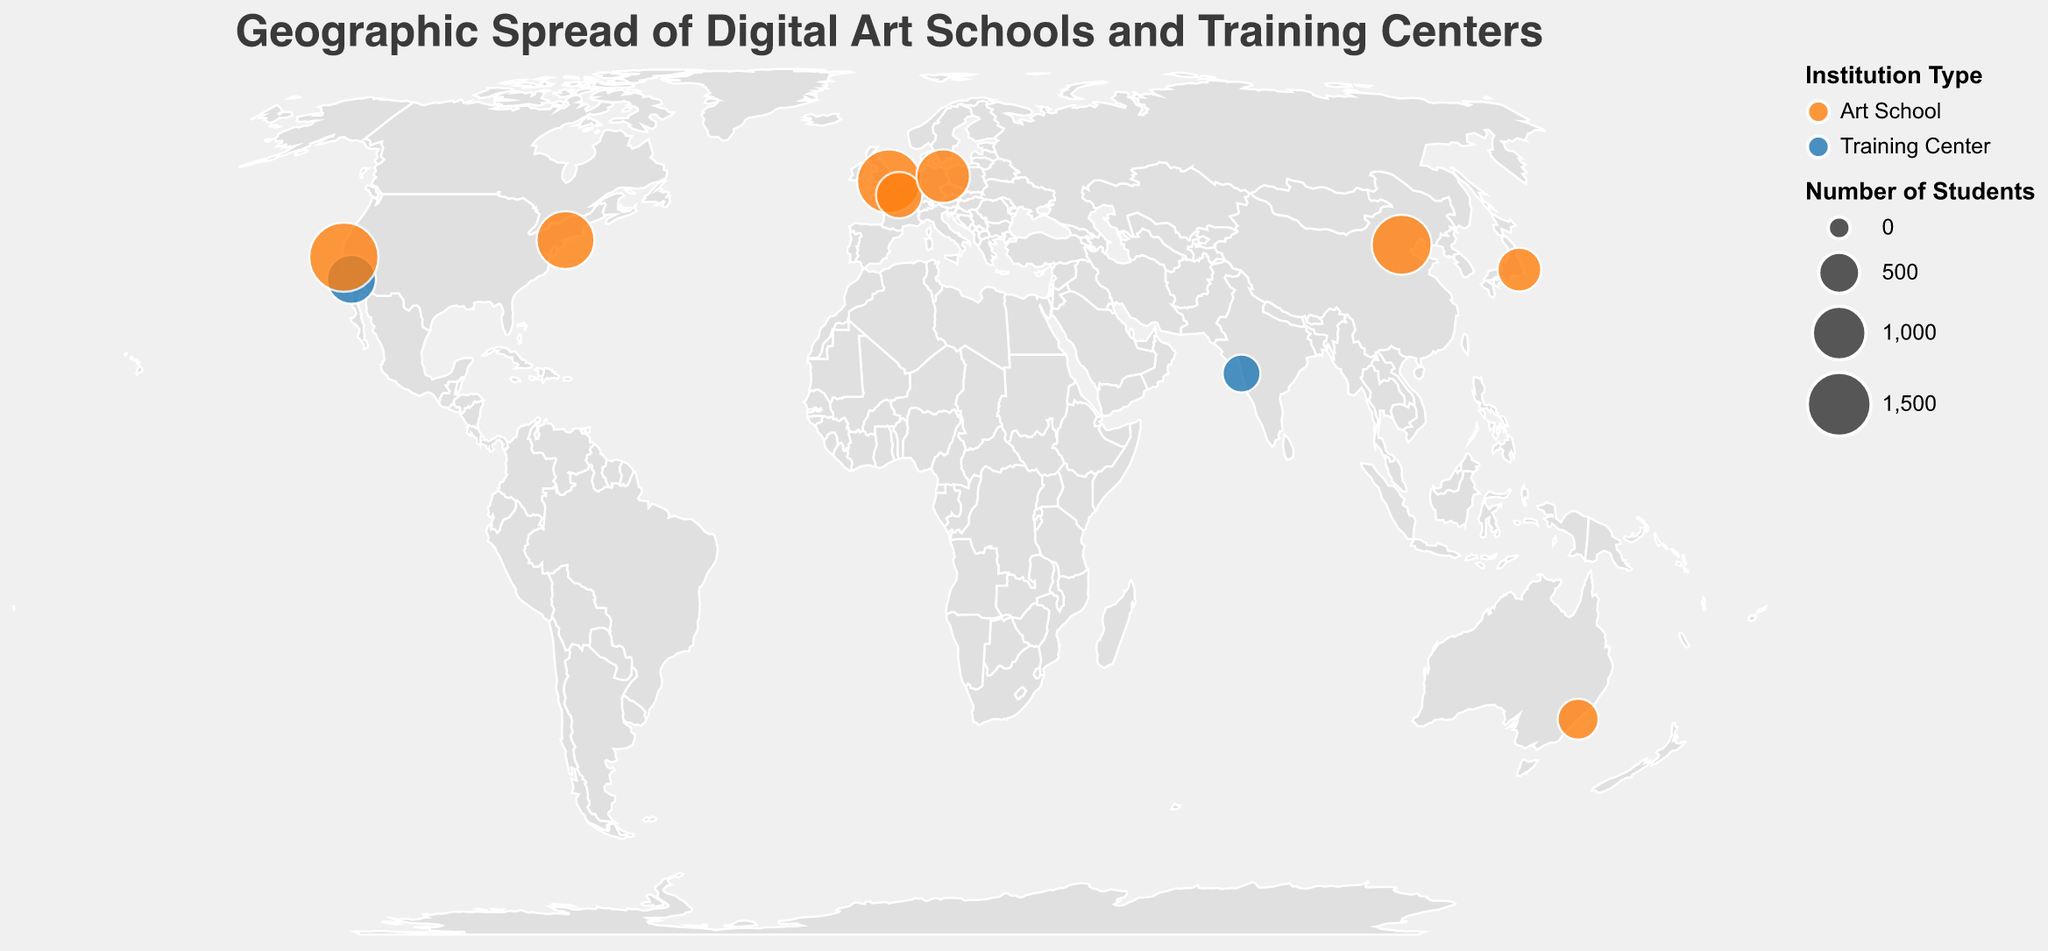What is the title of the figure? The title is usually the largest piece of text at the top of the plot. It helps identify the main topic of the visualization.
Answer: Geographic Spread of Digital Art Schools and Training Centers What color represents Art Schools on the map? In the legend, the color associated with "Art School" provides this information.
Answer: Orange How many schools and training centers are plotted on the map? The total number of circles on the map corresponds to the number of data points. Counting them will give an accurate answer.
Answer: 10 Which institution has the largest student population? Look for the largest-sized circle on the map since the size is proportional to the number of students.
Answer: Academy of Art University Which two institutions have the smallest student population? Identify the two smallest-sized circles on the map and check their tooltips to find the corresponding institutions.
Answer: Whistling Woods International and Billy Blue College of Design What's the total number of students in all institutions combined? Sum the student numbers given in the tooltip for each institution. (1200 + 800 + 1500 + 600 + 1800 + 700 + 500 + 1000 + 1300 + 400) = 9800
Answer: 9800 How many institutions are in the US? Identify the number of circles located within the US borders and check their tooltips to confirm.
Answer: 3 Which continent has the highest number of institutions represented on the map? Count the number of institutions (circles) on each continent and compare.
Answer: Europe Compare the number of students between London College of Communication and Central Academy of Fine Arts. Which has more? Use the size of the circles and confirm with the tooltip data for both institutions. London College of Communication has 1500 students, and Central Academy of Fine Arts has 1300 students.
Answer: London College of Communication What is the average number of students in the training centers? Only include training centers in the calculation. Sum the students in Gnomon and Whistling Woods International (800 + 400) and divide by 2. (800 + 400) / 2 = 600
Answer: 600 